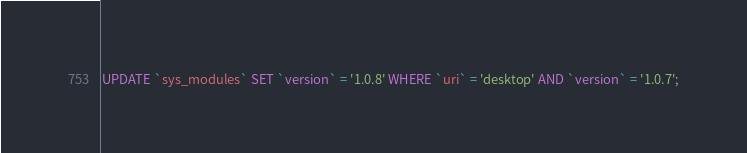<code> <loc_0><loc_0><loc_500><loc_500><_SQL_>

UPDATE `sys_modules` SET `version` = '1.0.8' WHERE `uri` = 'desktop' AND `version` = '1.0.7';

</code> 